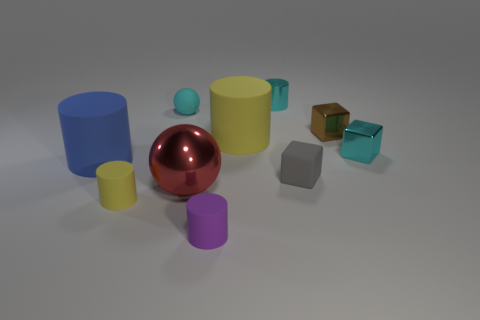Is the color of the shiny cylinder that is behind the big blue rubber object the same as the rubber sphere?
Provide a short and direct response. Yes. What color is the large cylinder that is the same material as the blue thing?
Your answer should be very brief. Yellow. Is the purple matte thing the same size as the blue rubber cylinder?
Offer a very short reply. No. What is the material of the purple object that is the same size as the gray rubber block?
Your answer should be compact. Rubber. Is the number of small yellow rubber cylinders behind the brown object the same as the number of things that are on the left side of the metallic ball?
Ensure brevity in your answer.  No. The yellow cylinder that is behind the yellow cylinder in front of the ball that is in front of the small gray block is made of what material?
Offer a very short reply. Rubber. What is the color of the metal thing that is left of the cyan shiny object that is left of the small brown cube?
Offer a very short reply. Red. There is a yellow matte cylinder right of the cyan matte ball; what is its size?
Keep it short and to the point. Large. What is the shape of the yellow thing in front of the big cylinder on the left side of the red object?
Offer a very short reply. Cylinder. There is a rubber cylinder on the left side of the yellow object that is in front of the tiny gray cube; what number of small things are behind it?
Your answer should be compact. 4. 